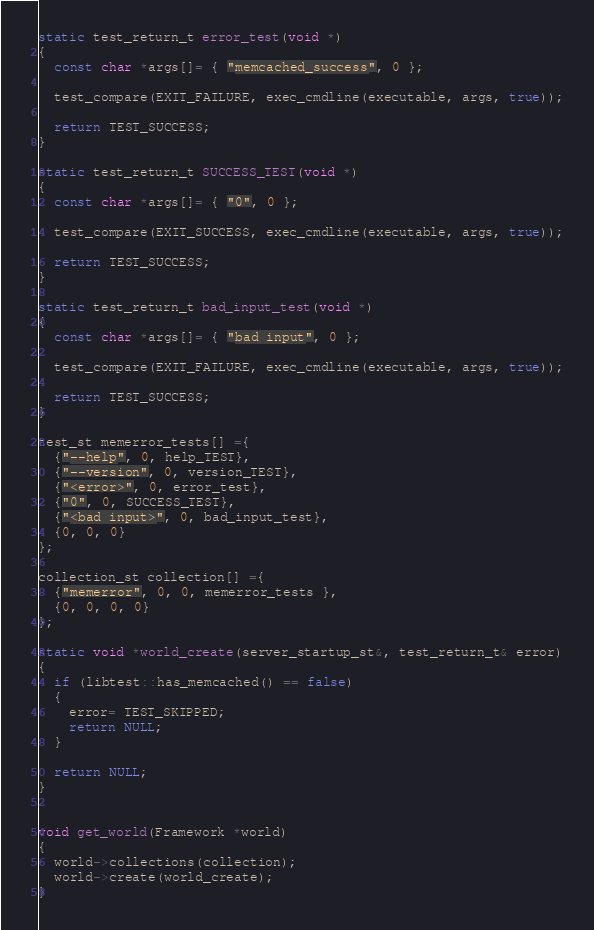Convert code to text. <code><loc_0><loc_0><loc_500><loc_500><_C++_>static test_return_t error_test(void *)
{
  const char *args[]= { "memcached_success", 0 };

  test_compare(EXIT_FAILURE, exec_cmdline(executable, args, true));

  return TEST_SUCCESS;
}

static test_return_t SUCCESS_TEST(void *)
{
  const char *args[]= { "0", 0 };

  test_compare(EXIT_SUCCESS, exec_cmdline(executable, args, true));

  return TEST_SUCCESS;
}

static test_return_t bad_input_test(void *)
{
  const char *args[]= { "bad input", 0 };

  test_compare(EXIT_FAILURE, exec_cmdline(executable, args, true));

  return TEST_SUCCESS;
}

test_st memerror_tests[] ={
  {"--help", 0, help_TEST},
  {"--version", 0, version_TEST},
  {"<error>", 0, error_test},
  {"0", 0, SUCCESS_TEST},
  {"<bad input>", 0, bad_input_test},
  {0, 0, 0}
};

collection_st collection[] ={
  {"memerror", 0, 0, memerror_tests },
  {0, 0, 0, 0}
};

static void *world_create(server_startup_st&, test_return_t& error)
{
  if (libtest::has_memcached() == false)
  {
    error= TEST_SKIPPED;
    return NULL;
  }

  return NULL;
}


void get_world(Framework *world)
{
  world->collections(collection);
  world->create(world_create);
}

</code> 